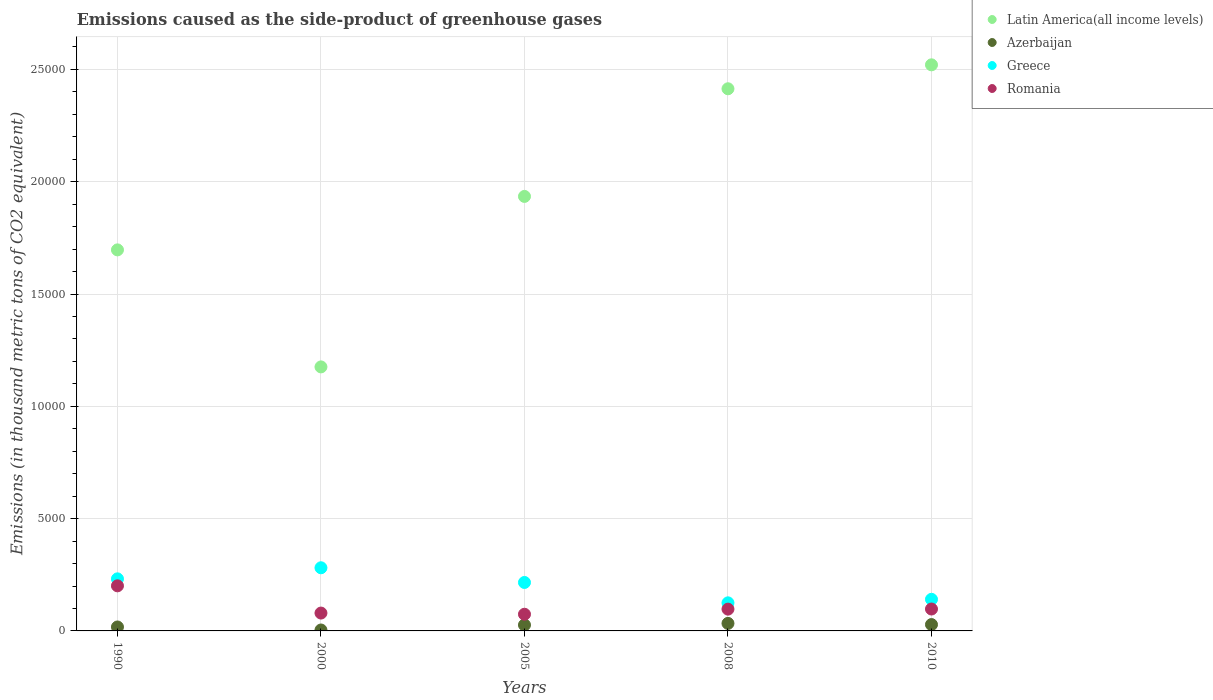What is the emissions caused as the side-product of greenhouse gases in Latin America(all income levels) in 2010?
Give a very brief answer. 2.52e+04. Across all years, what is the maximum emissions caused as the side-product of greenhouse gases in Azerbaijan?
Offer a terse response. 335.3. Across all years, what is the minimum emissions caused as the side-product of greenhouse gases in Azerbaijan?
Give a very brief answer. 41.3. What is the total emissions caused as the side-product of greenhouse gases in Greece in the graph?
Make the answer very short. 9944.2. What is the difference between the emissions caused as the side-product of greenhouse gases in Latin America(all income levels) in 1990 and that in 2000?
Your answer should be compact. 5210.5. What is the difference between the emissions caused as the side-product of greenhouse gases in Azerbaijan in 2010 and the emissions caused as the side-product of greenhouse gases in Latin America(all income levels) in 2008?
Offer a terse response. -2.39e+04. What is the average emissions caused as the side-product of greenhouse gases in Latin America(all income levels) per year?
Give a very brief answer. 1.95e+04. In the year 2008, what is the difference between the emissions caused as the side-product of greenhouse gases in Azerbaijan and emissions caused as the side-product of greenhouse gases in Latin America(all income levels)?
Your answer should be compact. -2.38e+04. In how many years, is the emissions caused as the side-product of greenhouse gases in Azerbaijan greater than 6000 thousand metric tons?
Your response must be concise. 0. What is the ratio of the emissions caused as the side-product of greenhouse gases in Azerbaijan in 2005 to that in 2010?
Keep it short and to the point. 0.94. Is the emissions caused as the side-product of greenhouse gases in Greece in 1990 less than that in 2010?
Keep it short and to the point. No. What is the difference between the highest and the second highest emissions caused as the side-product of greenhouse gases in Latin America(all income levels)?
Provide a succinct answer. 1065.6. What is the difference between the highest and the lowest emissions caused as the side-product of greenhouse gases in Azerbaijan?
Your answer should be compact. 294. In how many years, is the emissions caused as the side-product of greenhouse gases in Romania greater than the average emissions caused as the side-product of greenhouse gases in Romania taken over all years?
Your answer should be compact. 1. Is the sum of the emissions caused as the side-product of greenhouse gases in Latin America(all income levels) in 2000 and 2005 greater than the maximum emissions caused as the side-product of greenhouse gases in Azerbaijan across all years?
Your response must be concise. Yes. Is it the case that in every year, the sum of the emissions caused as the side-product of greenhouse gases in Greece and emissions caused as the side-product of greenhouse gases in Azerbaijan  is greater than the sum of emissions caused as the side-product of greenhouse gases in Latin America(all income levels) and emissions caused as the side-product of greenhouse gases in Romania?
Your answer should be compact. No. Is it the case that in every year, the sum of the emissions caused as the side-product of greenhouse gases in Azerbaijan and emissions caused as the side-product of greenhouse gases in Latin America(all income levels)  is greater than the emissions caused as the side-product of greenhouse gases in Greece?
Your response must be concise. Yes. Does the emissions caused as the side-product of greenhouse gases in Latin America(all income levels) monotonically increase over the years?
Give a very brief answer. No. How many dotlines are there?
Your answer should be very brief. 4. How many years are there in the graph?
Offer a very short reply. 5. Does the graph contain any zero values?
Make the answer very short. No. Does the graph contain grids?
Give a very brief answer. Yes. What is the title of the graph?
Your answer should be very brief. Emissions caused as the side-product of greenhouse gases. Does "St. Lucia" appear as one of the legend labels in the graph?
Give a very brief answer. No. What is the label or title of the Y-axis?
Make the answer very short. Emissions (in thousand metric tons of CO2 equivalent). What is the Emissions (in thousand metric tons of CO2 equivalent) in Latin America(all income levels) in 1990?
Make the answer very short. 1.70e+04. What is the Emissions (in thousand metric tons of CO2 equivalent) in Azerbaijan in 1990?
Provide a succinct answer. 175.6. What is the Emissions (in thousand metric tons of CO2 equivalent) of Greece in 1990?
Your response must be concise. 2318.5. What is the Emissions (in thousand metric tons of CO2 equivalent) in Romania in 1990?
Give a very brief answer. 2007.7. What is the Emissions (in thousand metric tons of CO2 equivalent) of Latin America(all income levels) in 2000?
Your answer should be compact. 1.18e+04. What is the Emissions (in thousand metric tons of CO2 equivalent) of Azerbaijan in 2000?
Your response must be concise. 41.3. What is the Emissions (in thousand metric tons of CO2 equivalent) in Greece in 2000?
Offer a very short reply. 2811.5. What is the Emissions (in thousand metric tons of CO2 equivalent) in Romania in 2000?
Offer a terse response. 795.1. What is the Emissions (in thousand metric tons of CO2 equivalent) of Latin America(all income levels) in 2005?
Provide a short and direct response. 1.93e+04. What is the Emissions (in thousand metric tons of CO2 equivalent) in Azerbaijan in 2005?
Make the answer very short. 265.1. What is the Emissions (in thousand metric tons of CO2 equivalent) in Greece in 2005?
Your response must be concise. 2157. What is the Emissions (in thousand metric tons of CO2 equivalent) in Romania in 2005?
Provide a succinct answer. 742.3. What is the Emissions (in thousand metric tons of CO2 equivalent) of Latin America(all income levels) in 2008?
Make the answer very short. 2.41e+04. What is the Emissions (in thousand metric tons of CO2 equivalent) in Azerbaijan in 2008?
Give a very brief answer. 335.3. What is the Emissions (in thousand metric tons of CO2 equivalent) of Greece in 2008?
Offer a terse response. 1250.2. What is the Emissions (in thousand metric tons of CO2 equivalent) in Romania in 2008?
Make the answer very short. 970.3. What is the Emissions (in thousand metric tons of CO2 equivalent) of Latin America(all income levels) in 2010?
Offer a very short reply. 2.52e+04. What is the Emissions (in thousand metric tons of CO2 equivalent) in Azerbaijan in 2010?
Keep it short and to the point. 283. What is the Emissions (in thousand metric tons of CO2 equivalent) in Greece in 2010?
Keep it short and to the point. 1407. What is the Emissions (in thousand metric tons of CO2 equivalent) of Romania in 2010?
Give a very brief answer. 975. Across all years, what is the maximum Emissions (in thousand metric tons of CO2 equivalent) of Latin America(all income levels)?
Offer a terse response. 2.52e+04. Across all years, what is the maximum Emissions (in thousand metric tons of CO2 equivalent) of Azerbaijan?
Make the answer very short. 335.3. Across all years, what is the maximum Emissions (in thousand metric tons of CO2 equivalent) in Greece?
Keep it short and to the point. 2811.5. Across all years, what is the maximum Emissions (in thousand metric tons of CO2 equivalent) in Romania?
Offer a terse response. 2007.7. Across all years, what is the minimum Emissions (in thousand metric tons of CO2 equivalent) of Latin America(all income levels)?
Make the answer very short. 1.18e+04. Across all years, what is the minimum Emissions (in thousand metric tons of CO2 equivalent) in Azerbaijan?
Give a very brief answer. 41.3. Across all years, what is the minimum Emissions (in thousand metric tons of CO2 equivalent) in Greece?
Ensure brevity in your answer.  1250.2. Across all years, what is the minimum Emissions (in thousand metric tons of CO2 equivalent) of Romania?
Your response must be concise. 742.3. What is the total Emissions (in thousand metric tons of CO2 equivalent) of Latin America(all income levels) in the graph?
Offer a terse response. 9.74e+04. What is the total Emissions (in thousand metric tons of CO2 equivalent) in Azerbaijan in the graph?
Ensure brevity in your answer.  1100.3. What is the total Emissions (in thousand metric tons of CO2 equivalent) in Greece in the graph?
Provide a short and direct response. 9944.2. What is the total Emissions (in thousand metric tons of CO2 equivalent) of Romania in the graph?
Offer a very short reply. 5490.4. What is the difference between the Emissions (in thousand metric tons of CO2 equivalent) of Latin America(all income levels) in 1990 and that in 2000?
Offer a very short reply. 5210.5. What is the difference between the Emissions (in thousand metric tons of CO2 equivalent) of Azerbaijan in 1990 and that in 2000?
Your response must be concise. 134.3. What is the difference between the Emissions (in thousand metric tons of CO2 equivalent) of Greece in 1990 and that in 2000?
Keep it short and to the point. -493. What is the difference between the Emissions (in thousand metric tons of CO2 equivalent) of Romania in 1990 and that in 2000?
Provide a succinct answer. 1212.6. What is the difference between the Emissions (in thousand metric tons of CO2 equivalent) in Latin America(all income levels) in 1990 and that in 2005?
Ensure brevity in your answer.  -2380.3. What is the difference between the Emissions (in thousand metric tons of CO2 equivalent) in Azerbaijan in 1990 and that in 2005?
Provide a short and direct response. -89.5. What is the difference between the Emissions (in thousand metric tons of CO2 equivalent) in Greece in 1990 and that in 2005?
Offer a terse response. 161.5. What is the difference between the Emissions (in thousand metric tons of CO2 equivalent) of Romania in 1990 and that in 2005?
Your answer should be compact. 1265.4. What is the difference between the Emissions (in thousand metric tons of CO2 equivalent) in Latin America(all income levels) in 1990 and that in 2008?
Provide a short and direct response. -7173.6. What is the difference between the Emissions (in thousand metric tons of CO2 equivalent) in Azerbaijan in 1990 and that in 2008?
Ensure brevity in your answer.  -159.7. What is the difference between the Emissions (in thousand metric tons of CO2 equivalent) of Greece in 1990 and that in 2008?
Your response must be concise. 1068.3. What is the difference between the Emissions (in thousand metric tons of CO2 equivalent) in Romania in 1990 and that in 2008?
Offer a very short reply. 1037.4. What is the difference between the Emissions (in thousand metric tons of CO2 equivalent) of Latin America(all income levels) in 1990 and that in 2010?
Offer a very short reply. -8239.2. What is the difference between the Emissions (in thousand metric tons of CO2 equivalent) of Azerbaijan in 1990 and that in 2010?
Your answer should be very brief. -107.4. What is the difference between the Emissions (in thousand metric tons of CO2 equivalent) of Greece in 1990 and that in 2010?
Give a very brief answer. 911.5. What is the difference between the Emissions (in thousand metric tons of CO2 equivalent) in Romania in 1990 and that in 2010?
Your answer should be compact. 1032.7. What is the difference between the Emissions (in thousand metric tons of CO2 equivalent) of Latin America(all income levels) in 2000 and that in 2005?
Your response must be concise. -7590.8. What is the difference between the Emissions (in thousand metric tons of CO2 equivalent) of Azerbaijan in 2000 and that in 2005?
Your answer should be compact. -223.8. What is the difference between the Emissions (in thousand metric tons of CO2 equivalent) of Greece in 2000 and that in 2005?
Make the answer very short. 654.5. What is the difference between the Emissions (in thousand metric tons of CO2 equivalent) in Romania in 2000 and that in 2005?
Ensure brevity in your answer.  52.8. What is the difference between the Emissions (in thousand metric tons of CO2 equivalent) in Latin America(all income levels) in 2000 and that in 2008?
Give a very brief answer. -1.24e+04. What is the difference between the Emissions (in thousand metric tons of CO2 equivalent) in Azerbaijan in 2000 and that in 2008?
Ensure brevity in your answer.  -294. What is the difference between the Emissions (in thousand metric tons of CO2 equivalent) in Greece in 2000 and that in 2008?
Offer a very short reply. 1561.3. What is the difference between the Emissions (in thousand metric tons of CO2 equivalent) in Romania in 2000 and that in 2008?
Ensure brevity in your answer.  -175.2. What is the difference between the Emissions (in thousand metric tons of CO2 equivalent) of Latin America(all income levels) in 2000 and that in 2010?
Make the answer very short. -1.34e+04. What is the difference between the Emissions (in thousand metric tons of CO2 equivalent) of Azerbaijan in 2000 and that in 2010?
Your answer should be very brief. -241.7. What is the difference between the Emissions (in thousand metric tons of CO2 equivalent) of Greece in 2000 and that in 2010?
Give a very brief answer. 1404.5. What is the difference between the Emissions (in thousand metric tons of CO2 equivalent) of Romania in 2000 and that in 2010?
Offer a very short reply. -179.9. What is the difference between the Emissions (in thousand metric tons of CO2 equivalent) in Latin America(all income levels) in 2005 and that in 2008?
Provide a succinct answer. -4793.3. What is the difference between the Emissions (in thousand metric tons of CO2 equivalent) of Azerbaijan in 2005 and that in 2008?
Ensure brevity in your answer.  -70.2. What is the difference between the Emissions (in thousand metric tons of CO2 equivalent) of Greece in 2005 and that in 2008?
Give a very brief answer. 906.8. What is the difference between the Emissions (in thousand metric tons of CO2 equivalent) of Romania in 2005 and that in 2008?
Keep it short and to the point. -228. What is the difference between the Emissions (in thousand metric tons of CO2 equivalent) of Latin America(all income levels) in 2005 and that in 2010?
Make the answer very short. -5858.9. What is the difference between the Emissions (in thousand metric tons of CO2 equivalent) in Azerbaijan in 2005 and that in 2010?
Provide a short and direct response. -17.9. What is the difference between the Emissions (in thousand metric tons of CO2 equivalent) of Greece in 2005 and that in 2010?
Your response must be concise. 750. What is the difference between the Emissions (in thousand metric tons of CO2 equivalent) of Romania in 2005 and that in 2010?
Offer a very short reply. -232.7. What is the difference between the Emissions (in thousand metric tons of CO2 equivalent) in Latin America(all income levels) in 2008 and that in 2010?
Give a very brief answer. -1065.6. What is the difference between the Emissions (in thousand metric tons of CO2 equivalent) in Azerbaijan in 2008 and that in 2010?
Your answer should be very brief. 52.3. What is the difference between the Emissions (in thousand metric tons of CO2 equivalent) of Greece in 2008 and that in 2010?
Your answer should be very brief. -156.8. What is the difference between the Emissions (in thousand metric tons of CO2 equivalent) of Romania in 2008 and that in 2010?
Provide a succinct answer. -4.7. What is the difference between the Emissions (in thousand metric tons of CO2 equivalent) in Latin America(all income levels) in 1990 and the Emissions (in thousand metric tons of CO2 equivalent) in Azerbaijan in 2000?
Keep it short and to the point. 1.69e+04. What is the difference between the Emissions (in thousand metric tons of CO2 equivalent) of Latin America(all income levels) in 1990 and the Emissions (in thousand metric tons of CO2 equivalent) of Greece in 2000?
Provide a succinct answer. 1.42e+04. What is the difference between the Emissions (in thousand metric tons of CO2 equivalent) in Latin America(all income levels) in 1990 and the Emissions (in thousand metric tons of CO2 equivalent) in Romania in 2000?
Ensure brevity in your answer.  1.62e+04. What is the difference between the Emissions (in thousand metric tons of CO2 equivalent) in Azerbaijan in 1990 and the Emissions (in thousand metric tons of CO2 equivalent) in Greece in 2000?
Give a very brief answer. -2635.9. What is the difference between the Emissions (in thousand metric tons of CO2 equivalent) in Azerbaijan in 1990 and the Emissions (in thousand metric tons of CO2 equivalent) in Romania in 2000?
Offer a terse response. -619.5. What is the difference between the Emissions (in thousand metric tons of CO2 equivalent) of Greece in 1990 and the Emissions (in thousand metric tons of CO2 equivalent) of Romania in 2000?
Your response must be concise. 1523.4. What is the difference between the Emissions (in thousand metric tons of CO2 equivalent) of Latin America(all income levels) in 1990 and the Emissions (in thousand metric tons of CO2 equivalent) of Azerbaijan in 2005?
Make the answer very short. 1.67e+04. What is the difference between the Emissions (in thousand metric tons of CO2 equivalent) of Latin America(all income levels) in 1990 and the Emissions (in thousand metric tons of CO2 equivalent) of Greece in 2005?
Ensure brevity in your answer.  1.48e+04. What is the difference between the Emissions (in thousand metric tons of CO2 equivalent) of Latin America(all income levels) in 1990 and the Emissions (in thousand metric tons of CO2 equivalent) of Romania in 2005?
Offer a terse response. 1.62e+04. What is the difference between the Emissions (in thousand metric tons of CO2 equivalent) in Azerbaijan in 1990 and the Emissions (in thousand metric tons of CO2 equivalent) in Greece in 2005?
Provide a succinct answer. -1981.4. What is the difference between the Emissions (in thousand metric tons of CO2 equivalent) of Azerbaijan in 1990 and the Emissions (in thousand metric tons of CO2 equivalent) of Romania in 2005?
Your answer should be very brief. -566.7. What is the difference between the Emissions (in thousand metric tons of CO2 equivalent) of Greece in 1990 and the Emissions (in thousand metric tons of CO2 equivalent) of Romania in 2005?
Make the answer very short. 1576.2. What is the difference between the Emissions (in thousand metric tons of CO2 equivalent) of Latin America(all income levels) in 1990 and the Emissions (in thousand metric tons of CO2 equivalent) of Azerbaijan in 2008?
Your answer should be compact. 1.66e+04. What is the difference between the Emissions (in thousand metric tons of CO2 equivalent) in Latin America(all income levels) in 1990 and the Emissions (in thousand metric tons of CO2 equivalent) in Greece in 2008?
Give a very brief answer. 1.57e+04. What is the difference between the Emissions (in thousand metric tons of CO2 equivalent) of Latin America(all income levels) in 1990 and the Emissions (in thousand metric tons of CO2 equivalent) of Romania in 2008?
Keep it short and to the point. 1.60e+04. What is the difference between the Emissions (in thousand metric tons of CO2 equivalent) of Azerbaijan in 1990 and the Emissions (in thousand metric tons of CO2 equivalent) of Greece in 2008?
Your answer should be very brief. -1074.6. What is the difference between the Emissions (in thousand metric tons of CO2 equivalent) of Azerbaijan in 1990 and the Emissions (in thousand metric tons of CO2 equivalent) of Romania in 2008?
Offer a terse response. -794.7. What is the difference between the Emissions (in thousand metric tons of CO2 equivalent) of Greece in 1990 and the Emissions (in thousand metric tons of CO2 equivalent) of Romania in 2008?
Make the answer very short. 1348.2. What is the difference between the Emissions (in thousand metric tons of CO2 equivalent) in Latin America(all income levels) in 1990 and the Emissions (in thousand metric tons of CO2 equivalent) in Azerbaijan in 2010?
Offer a terse response. 1.67e+04. What is the difference between the Emissions (in thousand metric tons of CO2 equivalent) in Latin America(all income levels) in 1990 and the Emissions (in thousand metric tons of CO2 equivalent) in Greece in 2010?
Your answer should be very brief. 1.56e+04. What is the difference between the Emissions (in thousand metric tons of CO2 equivalent) in Latin America(all income levels) in 1990 and the Emissions (in thousand metric tons of CO2 equivalent) in Romania in 2010?
Provide a short and direct response. 1.60e+04. What is the difference between the Emissions (in thousand metric tons of CO2 equivalent) of Azerbaijan in 1990 and the Emissions (in thousand metric tons of CO2 equivalent) of Greece in 2010?
Offer a very short reply. -1231.4. What is the difference between the Emissions (in thousand metric tons of CO2 equivalent) in Azerbaijan in 1990 and the Emissions (in thousand metric tons of CO2 equivalent) in Romania in 2010?
Provide a succinct answer. -799.4. What is the difference between the Emissions (in thousand metric tons of CO2 equivalent) in Greece in 1990 and the Emissions (in thousand metric tons of CO2 equivalent) in Romania in 2010?
Offer a very short reply. 1343.5. What is the difference between the Emissions (in thousand metric tons of CO2 equivalent) of Latin America(all income levels) in 2000 and the Emissions (in thousand metric tons of CO2 equivalent) of Azerbaijan in 2005?
Your answer should be compact. 1.15e+04. What is the difference between the Emissions (in thousand metric tons of CO2 equivalent) of Latin America(all income levels) in 2000 and the Emissions (in thousand metric tons of CO2 equivalent) of Greece in 2005?
Keep it short and to the point. 9598.3. What is the difference between the Emissions (in thousand metric tons of CO2 equivalent) in Latin America(all income levels) in 2000 and the Emissions (in thousand metric tons of CO2 equivalent) in Romania in 2005?
Your answer should be compact. 1.10e+04. What is the difference between the Emissions (in thousand metric tons of CO2 equivalent) of Azerbaijan in 2000 and the Emissions (in thousand metric tons of CO2 equivalent) of Greece in 2005?
Keep it short and to the point. -2115.7. What is the difference between the Emissions (in thousand metric tons of CO2 equivalent) of Azerbaijan in 2000 and the Emissions (in thousand metric tons of CO2 equivalent) of Romania in 2005?
Your response must be concise. -701. What is the difference between the Emissions (in thousand metric tons of CO2 equivalent) of Greece in 2000 and the Emissions (in thousand metric tons of CO2 equivalent) of Romania in 2005?
Offer a terse response. 2069.2. What is the difference between the Emissions (in thousand metric tons of CO2 equivalent) in Latin America(all income levels) in 2000 and the Emissions (in thousand metric tons of CO2 equivalent) in Azerbaijan in 2008?
Make the answer very short. 1.14e+04. What is the difference between the Emissions (in thousand metric tons of CO2 equivalent) in Latin America(all income levels) in 2000 and the Emissions (in thousand metric tons of CO2 equivalent) in Greece in 2008?
Provide a succinct answer. 1.05e+04. What is the difference between the Emissions (in thousand metric tons of CO2 equivalent) of Latin America(all income levels) in 2000 and the Emissions (in thousand metric tons of CO2 equivalent) of Romania in 2008?
Make the answer very short. 1.08e+04. What is the difference between the Emissions (in thousand metric tons of CO2 equivalent) in Azerbaijan in 2000 and the Emissions (in thousand metric tons of CO2 equivalent) in Greece in 2008?
Make the answer very short. -1208.9. What is the difference between the Emissions (in thousand metric tons of CO2 equivalent) of Azerbaijan in 2000 and the Emissions (in thousand metric tons of CO2 equivalent) of Romania in 2008?
Your answer should be compact. -929. What is the difference between the Emissions (in thousand metric tons of CO2 equivalent) in Greece in 2000 and the Emissions (in thousand metric tons of CO2 equivalent) in Romania in 2008?
Offer a very short reply. 1841.2. What is the difference between the Emissions (in thousand metric tons of CO2 equivalent) in Latin America(all income levels) in 2000 and the Emissions (in thousand metric tons of CO2 equivalent) in Azerbaijan in 2010?
Provide a succinct answer. 1.15e+04. What is the difference between the Emissions (in thousand metric tons of CO2 equivalent) of Latin America(all income levels) in 2000 and the Emissions (in thousand metric tons of CO2 equivalent) of Greece in 2010?
Your answer should be very brief. 1.03e+04. What is the difference between the Emissions (in thousand metric tons of CO2 equivalent) of Latin America(all income levels) in 2000 and the Emissions (in thousand metric tons of CO2 equivalent) of Romania in 2010?
Give a very brief answer. 1.08e+04. What is the difference between the Emissions (in thousand metric tons of CO2 equivalent) of Azerbaijan in 2000 and the Emissions (in thousand metric tons of CO2 equivalent) of Greece in 2010?
Offer a very short reply. -1365.7. What is the difference between the Emissions (in thousand metric tons of CO2 equivalent) in Azerbaijan in 2000 and the Emissions (in thousand metric tons of CO2 equivalent) in Romania in 2010?
Your answer should be compact. -933.7. What is the difference between the Emissions (in thousand metric tons of CO2 equivalent) of Greece in 2000 and the Emissions (in thousand metric tons of CO2 equivalent) of Romania in 2010?
Provide a short and direct response. 1836.5. What is the difference between the Emissions (in thousand metric tons of CO2 equivalent) of Latin America(all income levels) in 2005 and the Emissions (in thousand metric tons of CO2 equivalent) of Azerbaijan in 2008?
Your answer should be very brief. 1.90e+04. What is the difference between the Emissions (in thousand metric tons of CO2 equivalent) of Latin America(all income levels) in 2005 and the Emissions (in thousand metric tons of CO2 equivalent) of Greece in 2008?
Your answer should be very brief. 1.81e+04. What is the difference between the Emissions (in thousand metric tons of CO2 equivalent) of Latin America(all income levels) in 2005 and the Emissions (in thousand metric tons of CO2 equivalent) of Romania in 2008?
Provide a short and direct response. 1.84e+04. What is the difference between the Emissions (in thousand metric tons of CO2 equivalent) in Azerbaijan in 2005 and the Emissions (in thousand metric tons of CO2 equivalent) in Greece in 2008?
Provide a succinct answer. -985.1. What is the difference between the Emissions (in thousand metric tons of CO2 equivalent) in Azerbaijan in 2005 and the Emissions (in thousand metric tons of CO2 equivalent) in Romania in 2008?
Offer a terse response. -705.2. What is the difference between the Emissions (in thousand metric tons of CO2 equivalent) in Greece in 2005 and the Emissions (in thousand metric tons of CO2 equivalent) in Romania in 2008?
Provide a succinct answer. 1186.7. What is the difference between the Emissions (in thousand metric tons of CO2 equivalent) of Latin America(all income levels) in 2005 and the Emissions (in thousand metric tons of CO2 equivalent) of Azerbaijan in 2010?
Make the answer very short. 1.91e+04. What is the difference between the Emissions (in thousand metric tons of CO2 equivalent) in Latin America(all income levels) in 2005 and the Emissions (in thousand metric tons of CO2 equivalent) in Greece in 2010?
Ensure brevity in your answer.  1.79e+04. What is the difference between the Emissions (in thousand metric tons of CO2 equivalent) of Latin America(all income levels) in 2005 and the Emissions (in thousand metric tons of CO2 equivalent) of Romania in 2010?
Your answer should be very brief. 1.84e+04. What is the difference between the Emissions (in thousand metric tons of CO2 equivalent) in Azerbaijan in 2005 and the Emissions (in thousand metric tons of CO2 equivalent) in Greece in 2010?
Your answer should be very brief. -1141.9. What is the difference between the Emissions (in thousand metric tons of CO2 equivalent) of Azerbaijan in 2005 and the Emissions (in thousand metric tons of CO2 equivalent) of Romania in 2010?
Provide a succinct answer. -709.9. What is the difference between the Emissions (in thousand metric tons of CO2 equivalent) of Greece in 2005 and the Emissions (in thousand metric tons of CO2 equivalent) of Romania in 2010?
Give a very brief answer. 1182. What is the difference between the Emissions (in thousand metric tons of CO2 equivalent) in Latin America(all income levels) in 2008 and the Emissions (in thousand metric tons of CO2 equivalent) in Azerbaijan in 2010?
Provide a succinct answer. 2.39e+04. What is the difference between the Emissions (in thousand metric tons of CO2 equivalent) of Latin America(all income levels) in 2008 and the Emissions (in thousand metric tons of CO2 equivalent) of Greece in 2010?
Ensure brevity in your answer.  2.27e+04. What is the difference between the Emissions (in thousand metric tons of CO2 equivalent) in Latin America(all income levels) in 2008 and the Emissions (in thousand metric tons of CO2 equivalent) in Romania in 2010?
Your response must be concise. 2.32e+04. What is the difference between the Emissions (in thousand metric tons of CO2 equivalent) of Azerbaijan in 2008 and the Emissions (in thousand metric tons of CO2 equivalent) of Greece in 2010?
Your answer should be compact. -1071.7. What is the difference between the Emissions (in thousand metric tons of CO2 equivalent) in Azerbaijan in 2008 and the Emissions (in thousand metric tons of CO2 equivalent) in Romania in 2010?
Keep it short and to the point. -639.7. What is the difference between the Emissions (in thousand metric tons of CO2 equivalent) of Greece in 2008 and the Emissions (in thousand metric tons of CO2 equivalent) of Romania in 2010?
Offer a terse response. 275.2. What is the average Emissions (in thousand metric tons of CO2 equivalent) in Latin America(all income levels) per year?
Give a very brief answer. 1.95e+04. What is the average Emissions (in thousand metric tons of CO2 equivalent) of Azerbaijan per year?
Ensure brevity in your answer.  220.06. What is the average Emissions (in thousand metric tons of CO2 equivalent) in Greece per year?
Offer a very short reply. 1988.84. What is the average Emissions (in thousand metric tons of CO2 equivalent) in Romania per year?
Offer a terse response. 1098.08. In the year 1990, what is the difference between the Emissions (in thousand metric tons of CO2 equivalent) in Latin America(all income levels) and Emissions (in thousand metric tons of CO2 equivalent) in Azerbaijan?
Your response must be concise. 1.68e+04. In the year 1990, what is the difference between the Emissions (in thousand metric tons of CO2 equivalent) of Latin America(all income levels) and Emissions (in thousand metric tons of CO2 equivalent) of Greece?
Your answer should be very brief. 1.46e+04. In the year 1990, what is the difference between the Emissions (in thousand metric tons of CO2 equivalent) of Latin America(all income levels) and Emissions (in thousand metric tons of CO2 equivalent) of Romania?
Offer a terse response. 1.50e+04. In the year 1990, what is the difference between the Emissions (in thousand metric tons of CO2 equivalent) of Azerbaijan and Emissions (in thousand metric tons of CO2 equivalent) of Greece?
Offer a very short reply. -2142.9. In the year 1990, what is the difference between the Emissions (in thousand metric tons of CO2 equivalent) of Azerbaijan and Emissions (in thousand metric tons of CO2 equivalent) of Romania?
Ensure brevity in your answer.  -1832.1. In the year 1990, what is the difference between the Emissions (in thousand metric tons of CO2 equivalent) in Greece and Emissions (in thousand metric tons of CO2 equivalent) in Romania?
Provide a short and direct response. 310.8. In the year 2000, what is the difference between the Emissions (in thousand metric tons of CO2 equivalent) in Latin America(all income levels) and Emissions (in thousand metric tons of CO2 equivalent) in Azerbaijan?
Your response must be concise. 1.17e+04. In the year 2000, what is the difference between the Emissions (in thousand metric tons of CO2 equivalent) of Latin America(all income levels) and Emissions (in thousand metric tons of CO2 equivalent) of Greece?
Keep it short and to the point. 8943.8. In the year 2000, what is the difference between the Emissions (in thousand metric tons of CO2 equivalent) of Latin America(all income levels) and Emissions (in thousand metric tons of CO2 equivalent) of Romania?
Your response must be concise. 1.10e+04. In the year 2000, what is the difference between the Emissions (in thousand metric tons of CO2 equivalent) in Azerbaijan and Emissions (in thousand metric tons of CO2 equivalent) in Greece?
Give a very brief answer. -2770.2. In the year 2000, what is the difference between the Emissions (in thousand metric tons of CO2 equivalent) in Azerbaijan and Emissions (in thousand metric tons of CO2 equivalent) in Romania?
Provide a succinct answer. -753.8. In the year 2000, what is the difference between the Emissions (in thousand metric tons of CO2 equivalent) of Greece and Emissions (in thousand metric tons of CO2 equivalent) of Romania?
Your answer should be very brief. 2016.4. In the year 2005, what is the difference between the Emissions (in thousand metric tons of CO2 equivalent) of Latin America(all income levels) and Emissions (in thousand metric tons of CO2 equivalent) of Azerbaijan?
Keep it short and to the point. 1.91e+04. In the year 2005, what is the difference between the Emissions (in thousand metric tons of CO2 equivalent) in Latin America(all income levels) and Emissions (in thousand metric tons of CO2 equivalent) in Greece?
Provide a succinct answer. 1.72e+04. In the year 2005, what is the difference between the Emissions (in thousand metric tons of CO2 equivalent) in Latin America(all income levels) and Emissions (in thousand metric tons of CO2 equivalent) in Romania?
Give a very brief answer. 1.86e+04. In the year 2005, what is the difference between the Emissions (in thousand metric tons of CO2 equivalent) of Azerbaijan and Emissions (in thousand metric tons of CO2 equivalent) of Greece?
Keep it short and to the point. -1891.9. In the year 2005, what is the difference between the Emissions (in thousand metric tons of CO2 equivalent) of Azerbaijan and Emissions (in thousand metric tons of CO2 equivalent) of Romania?
Your response must be concise. -477.2. In the year 2005, what is the difference between the Emissions (in thousand metric tons of CO2 equivalent) in Greece and Emissions (in thousand metric tons of CO2 equivalent) in Romania?
Provide a succinct answer. 1414.7. In the year 2008, what is the difference between the Emissions (in thousand metric tons of CO2 equivalent) in Latin America(all income levels) and Emissions (in thousand metric tons of CO2 equivalent) in Azerbaijan?
Ensure brevity in your answer.  2.38e+04. In the year 2008, what is the difference between the Emissions (in thousand metric tons of CO2 equivalent) of Latin America(all income levels) and Emissions (in thousand metric tons of CO2 equivalent) of Greece?
Keep it short and to the point. 2.29e+04. In the year 2008, what is the difference between the Emissions (in thousand metric tons of CO2 equivalent) of Latin America(all income levels) and Emissions (in thousand metric tons of CO2 equivalent) of Romania?
Your answer should be compact. 2.32e+04. In the year 2008, what is the difference between the Emissions (in thousand metric tons of CO2 equivalent) of Azerbaijan and Emissions (in thousand metric tons of CO2 equivalent) of Greece?
Offer a very short reply. -914.9. In the year 2008, what is the difference between the Emissions (in thousand metric tons of CO2 equivalent) of Azerbaijan and Emissions (in thousand metric tons of CO2 equivalent) of Romania?
Provide a succinct answer. -635. In the year 2008, what is the difference between the Emissions (in thousand metric tons of CO2 equivalent) of Greece and Emissions (in thousand metric tons of CO2 equivalent) of Romania?
Offer a very short reply. 279.9. In the year 2010, what is the difference between the Emissions (in thousand metric tons of CO2 equivalent) in Latin America(all income levels) and Emissions (in thousand metric tons of CO2 equivalent) in Azerbaijan?
Your response must be concise. 2.49e+04. In the year 2010, what is the difference between the Emissions (in thousand metric tons of CO2 equivalent) of Latin America(all income levels) and Emissions (in thousand metric tons of CO2 equivalent) of Greece?
Your answer should be very brief. 2.38e+04. In the year 2010, what is the difference between the Emissions (in thousand metric tons of CO2 equivalent) in Latin America(all income levels) and Emissions (in thousand metric tons of CO2 equivalent) in Romania?
Provide a short and direct response. 2.42e+04. In the year 2010, what is the difference between the Emissions (in thousand metric tons of CO2 equivalent) of Azerbaijan and Emissions (in thousand metric tons of CO2 equivalent) of Greece?
Make the answer very short. -1124. In the year 2010, what is the difference between the Emissions (in thousand metric tons of CO2 equivalent) of Azerbaijan and Emissions (in thousand metric tons of CO2 equivalent) of Romania?
Your answer should be compact. -692. In the year 2010, what is the difference between the Emissions (in thousand metric tons of CO2 equivalent) in Greece and Emissions (in thousand metric tons of CO2 equivalent) in Romania?
Your answer should be compact. 432. What is the ratio of the Emissions (in thousand metric tons of CO2 equivalent) in Latin America(all income levels) in 1990 to that in 2000?
Make the answer very short. 1.44. What is the ratio of the Emissions (in thousand metric tons of CO2 equivalent) of Azerbaijan in 1990 to that in 2000?
Your answer should be compact. 4.25. What is the ratio of the Emissions (in thousand metric tons of CO2 equivalent) in Greece in 1990 to that in 2000?
Your answer should be compact. 0.82. What is the ratio of the Emissions (in thousand metric tons of CO2 equivalent) of Romania in 1990 to that in 2000?
Offer a very short reply. 2.53. What is the ratio of the Emissions (in thousand metric tons of CO2 equivalent) of Latin America(all income levels) in 1990 to that in 2005?
Ensure brevity in your answer.  0.88. What is the ratio of the Emissions (in thousand metric tons of CO2 equivalent) of Azerbaijan in 1990 to that in 2005?
Keep it short and to the point. 0.66. What is the ratio of the Emissions (in thousand metric tons of CO2 equivalent) of Greece in 1990 to that in 2005?
Your response must be concise. 1.07. What is the ratio of the Emissions (in thousand metric tons of CO2 equivalent) of Romania in 1990 to that in 2005?
Your answer should be very brief. 2.7. What is the ratio of the Emissions (in thousand metric tons of CO2 equivalent) of Latin America(all income levels) in 1990 to that in 2008?
Provide a short and direct response. 0.7. What is the ratio of the Emissions (in thousand metric tons of CO2 equivalent) of Azerbaijan in 1990 to that in 2008?
Provide a succinct answer. 0.52. What is the ratio of the Emissions (in thousand metric tons of CO2 equivalent) of Greece in 1990 to that in 2008?
Your response must be concise. 1.85. What is the ratio of the Emissions (in thousand metric tons of CO2 equivalent) of Romania in 1990 to that in 2008?
Offer a terse response. 2.07. What is the ratio of the Emissions (in thousand metric tons of CO2 equivalent) of Latin America(all income levels) in 1990 to that in 2010?
Your response must be concise. 0.67. What is the ratio of the Emissions (in thousand metric tons of CO2 equivalent) of Azerbaijan in 1990 to that in 2010?
Make the answer very short. 0.62. What is the ratio of the Emissions (in thousand metric tons of CO2 equivalent) in Greece in 1990 to that in 2010?
Your response must be concise. 1.65. What is the ratio of the Emissions (in thousand metric tons of CO2 equivalent) of Romania in 1990 to that in 2010?
Your response must be concise. 2.06. What is the ratio of the Emissions (in thousand metric tons of CO2 equivalent) of Latin America(all income levels) in 2000 to that in 2005?
Provide a short and direct response. 0.61. What is the ratio of the Emissions (in thousand metric tons of CO2 equivalent) of Azerbaijan in 2000 to that in 2005?
Your answer should be very brief. 0.16. What is the ratio of the Emissions (in thousand metric tons of CO2 equivalent) in Greece in 2000 to that in 2005?
Your answer should be very brief. 1.3. What is the ratio of the Emissions (in thousand metric tons of CO2 equivalent) in Romania in 2000 to that in 2005?
Keep it short and to the point. 1.07. What is the ratio of the Emissions (in thousand metric tons of CO2 equivalent) in Latin America(all income levels) in 2000 to that in 2008?
Keep it short and to the point. 0.49. What is the ratio of the Emissions (in thousand metric tons of CO2 equivalent) in Azerbaijan in 2000 to that in 2008?
Give a very brief answer. 0.12. What is the ratio of the Emissions (in thousand metric tons of CO2 equivalent) in Greece in 2000 to that in 2008?
Give a very brief answer. 2.25. What is the ratio of the Emissions (in thousand metric tons of CO2 equivalent) of Romania in 2000 to that in 2008?
Make the answer very short. 0.82. What is the ratio of the Emissions (in thousand metric tons of CO2 equivalent) in Latin America(all income levels) in 2000 to that in 2010?
Provide a short and direct response. 0.47. What is the ratio of the Emissions (in thousand metric tons of CO2 equivalent) of Azerbaijan in 2000 to that in 2010?
Provide a succinct answer. 0.15. What is the ratio of the Emissions (in thousand metric tons of CO2 equivalent) of Greece in 2000 to that in 2010?
Your answer should be very brief. 2. What is the ratio of the Emissions (in thousand metric tons of CO2 equivalent) of Romania in 2000 to that in 2010?
Keep it short and to the point. 0.82. What is the ratio of the Emissions (in thousand metric tons of CO2 equivalent) in Latin America(all income levels) in 2005 to that in 2008?
Offer a terse response. 0.8. What is the ratio of the Emissions (in thousand metric tons of CO2 equivalent) in Azerbaijan in 2005 to that in 2008?
Make the answer very short. 0.79. What is the ratio of the Emissions (in thousand metric tons of CO2 equivalent) of Greece in 2005 to that in 2008?
Your answer should be compact. 1.73. What is the ratio of the Emissions (in thousand metric tons of CO2 equivalent) of Romania in 2005 to that in 2008?
Your response must be concise. 0.77. What is the ratio of the Emissions (in thousand metric tons of CO2 equivalent) of Latin America(all income levels) in 2005 to that in 2010?
Offer a terse response. 0.77. What is the ratio of the Emissions (in thousand metric tons of CO2 equivalent) of Azerbaijan in 2005 to that in 2010?
Your answer should be very brief. 0.94. What is the ratio of the Emissions (in thousand metric tons of CO2 equivalent) in Greece in 2005 to that in 2010?
Provide a short and direct response. 1.53. What is the ratio of the Emissions (in thousand metric tons of CO2 equivalent) in Romania in 2005 to that in 2010?
Make the answer very short. 0.76. What is the ratio of the Emissions (in thousand metric tons of CO2 equivalent) of Latin America(all income levels) in 2008 to that in 2010?
Keep it short and to the point. 0.96. What is the ratio of the Emissions (in thousand metric tons of CO2 equivalent) in Azerbaijan in 2008 to that in 2010?
Keep it short and to the point. 1.18. What is the ratio of the Emissions (in thousand metric tons of CO2 equivalent) in Greece in 2008 to that in 2010?
Provide a short and direct response. 0.89. What is the ratio of the Emissions (in thousand metric tons of CO2 equivalent) of Romania in 2008 to that in 2010?
Ensure brevity in your answer.  1. What is the difference between the highest and the second highest Emissions (in thousand metric tons of CO2 equivalent) in Latin America(all income levels)?
Ensure brevity in your answer.  1065.6. What is the difference between the highest and the second highest Emissions (in thousand metric tons of CO2 equivalent) in Azerbaijan?
Your answer should be very brief. 52.3. What is the difference between the highest and the second highest Emissions (in thousand metric tons of CO2 equivalent) of Greece?
Provide a short and direct response. 493. What is the difference between the highest and the second highest Emissions (in thousand metric tons of CO2 equivalent) of Romania?
Provide a succinct answer. 1032.7. What is the difference between the highest and the lowest Emissions (in thousand metric tons of CO2 equivalent) in Latin America(all income levels)?
Provide a succinct answer. 1.34e+04. What is the difference between the highest and the lowest Emissions (in thousand metric tons of CO2 equivalent) of Azerbaijan?
Your answer should be compact. 294. What is the difference between the highest and the lowest Emissions (in thousand metric tons of CO2 equivalent) of Greece?
Make the answer very short. 1561.3. What is the difference between the highest and the lowest Emissions (in thousand metric tons of CO2 equivalent) of Romania?
Provide a short and direct response. 1265.4. 